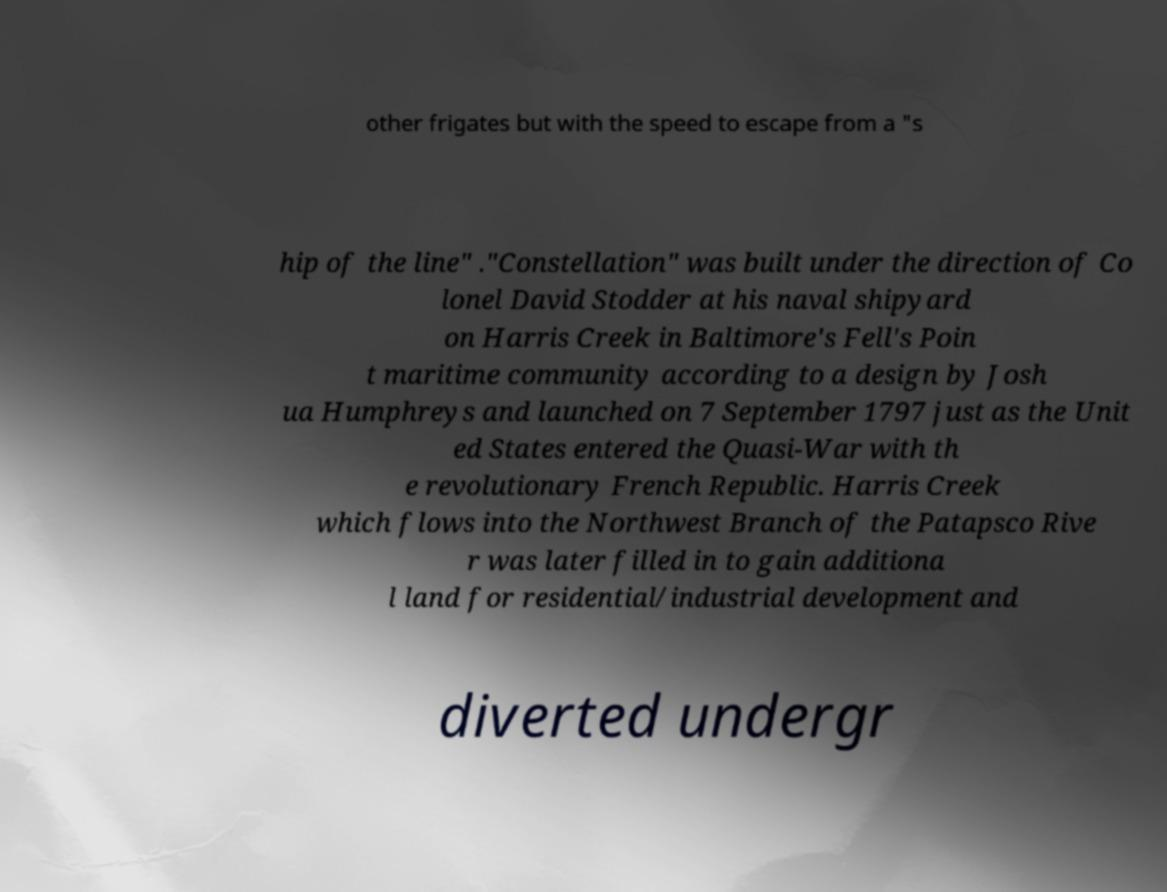Please read and relay the text visible in this image. What does it say? other frigates but with the speed to escape from a "s hip of the line" ."Constellation" was built under the direction of Co lonel David Stodder at his naval shipyard on Harris Creek in Baltimore's Fell's Poin t maritime community according to a design by Josh ua Humphreys and launched on 7 September 1797 just as the Unit ed States entered the Quasi-War with th e revolutionary French Republic. Harris Creek which flows into the Northwest Branch of the Patapsco Rive r was later filled in to gain additiona l land for residential/industrial development and diverted undergr 